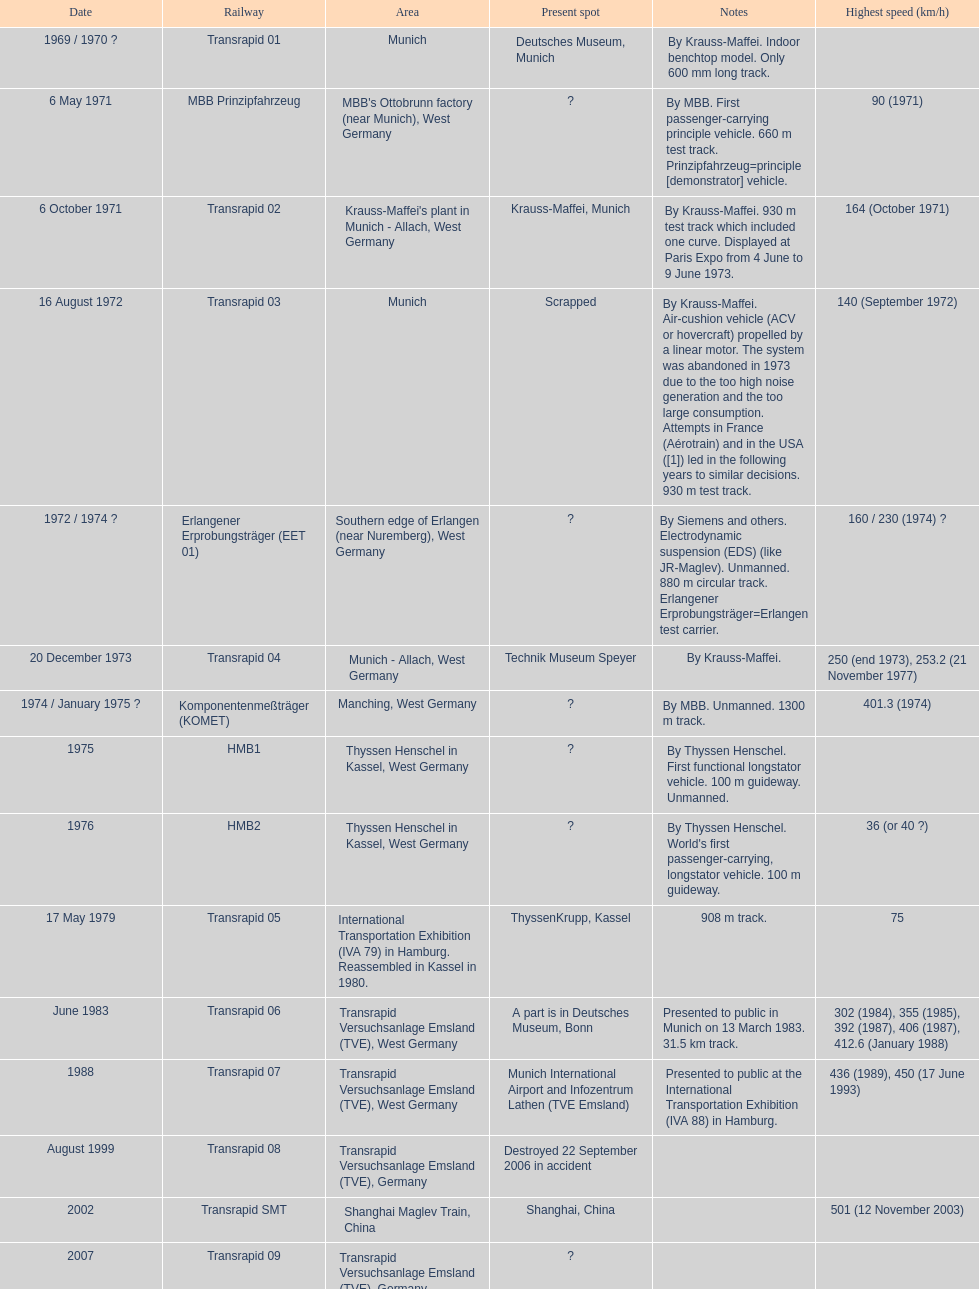Tell me the number of versions that are scrapped. 1. 